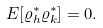Convert formula to latex. <formula><loc_0><loc_0><loc_500><loc_500>E [ \varrho ^ { * } _ { h } \varrho ^ { * } _ { k } ] = 0 .</formula> 